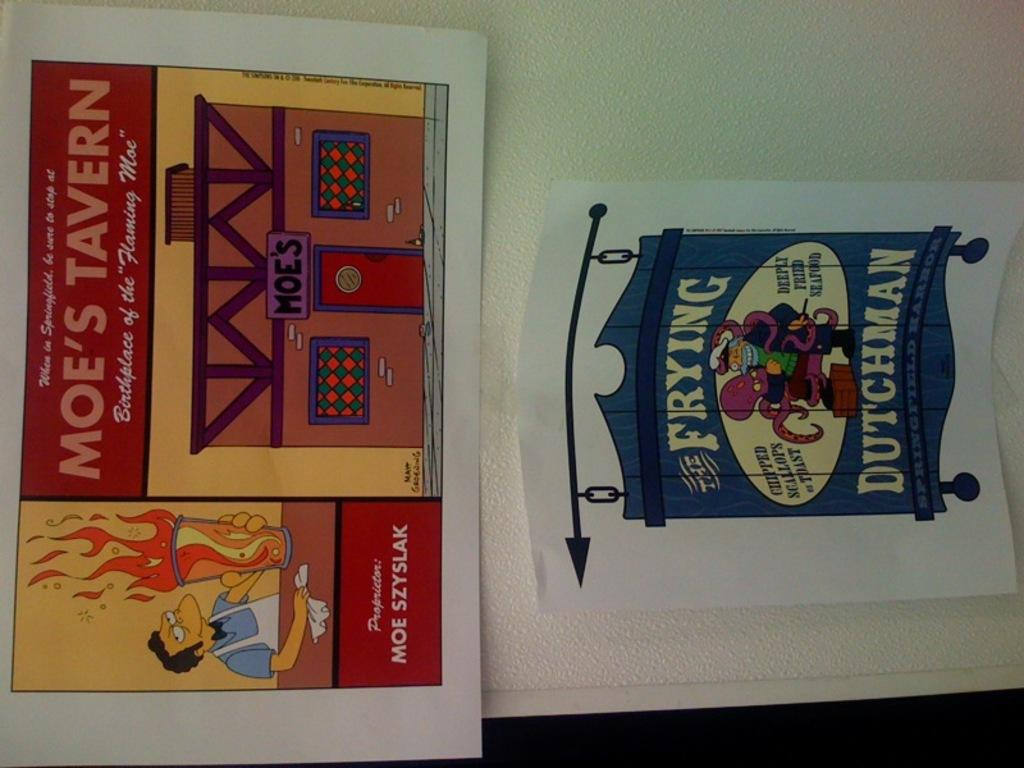Provide a one-sentence caption for the provided image. the word frying is on an ad with a Simpsons character. 